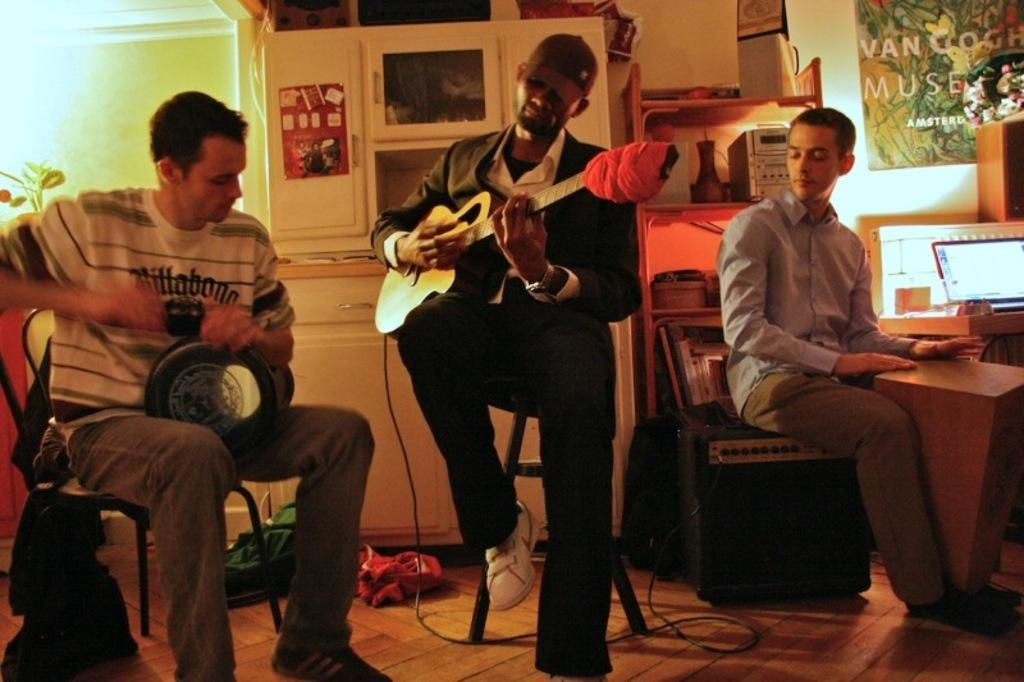How many people are present in the image? There are three people in the image. Where are the people located? The people are in a room. What are the people doing in the image? The people are playing musical instruments. What type of machine can be seen in the image? There is no machine present in the image; it features three people playing musical instruments. How does the rubbing of the instruments contribute to the music in the image? There is no rubbing of instruments mentioned in the image; the people are playing musical instruments, but the specific actions or techniques are not described. 